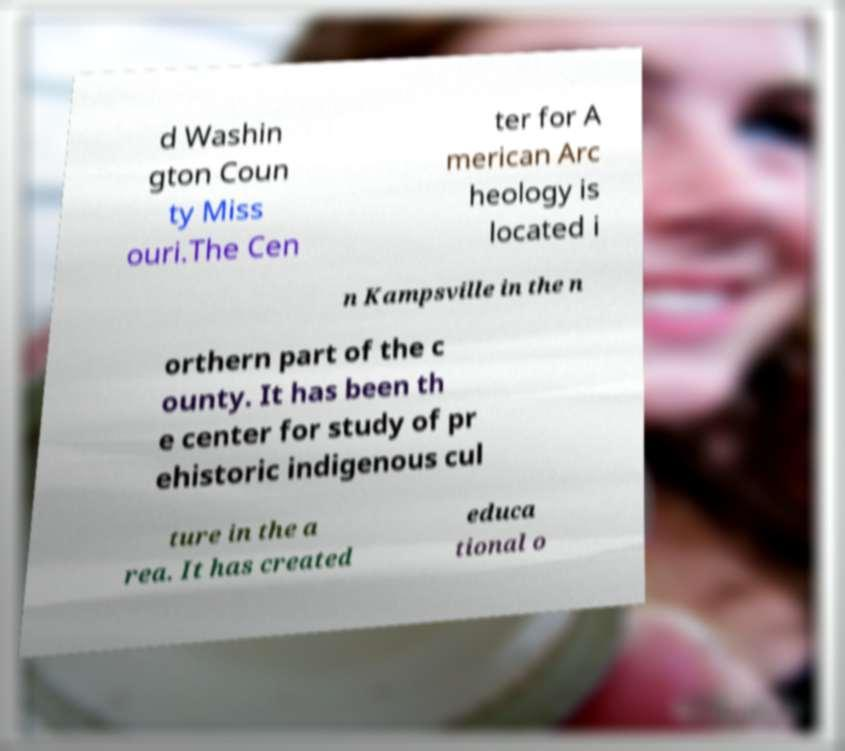What messages or text are displayed in this image? I need them in a readable, typed format. d Washin gton Coun ty Miss ouri.The Cen ter for A merican Arc heology is located i n Kampsville in the n orthern part of the c ounty. It has been th e center for study of pr ehistoric indigenous cul ture in the a rea. It has created educa tional o 